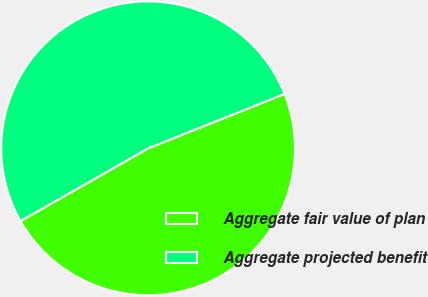Convert chart. <chart><loc_0><loc_0><loc_500><loc_500><pie_chart><fcel>Aggregate fair value of plan<fcel>Aggregate projected benefit<nl><fcel>47.8%<fcel>52.2%<nl></chart> 